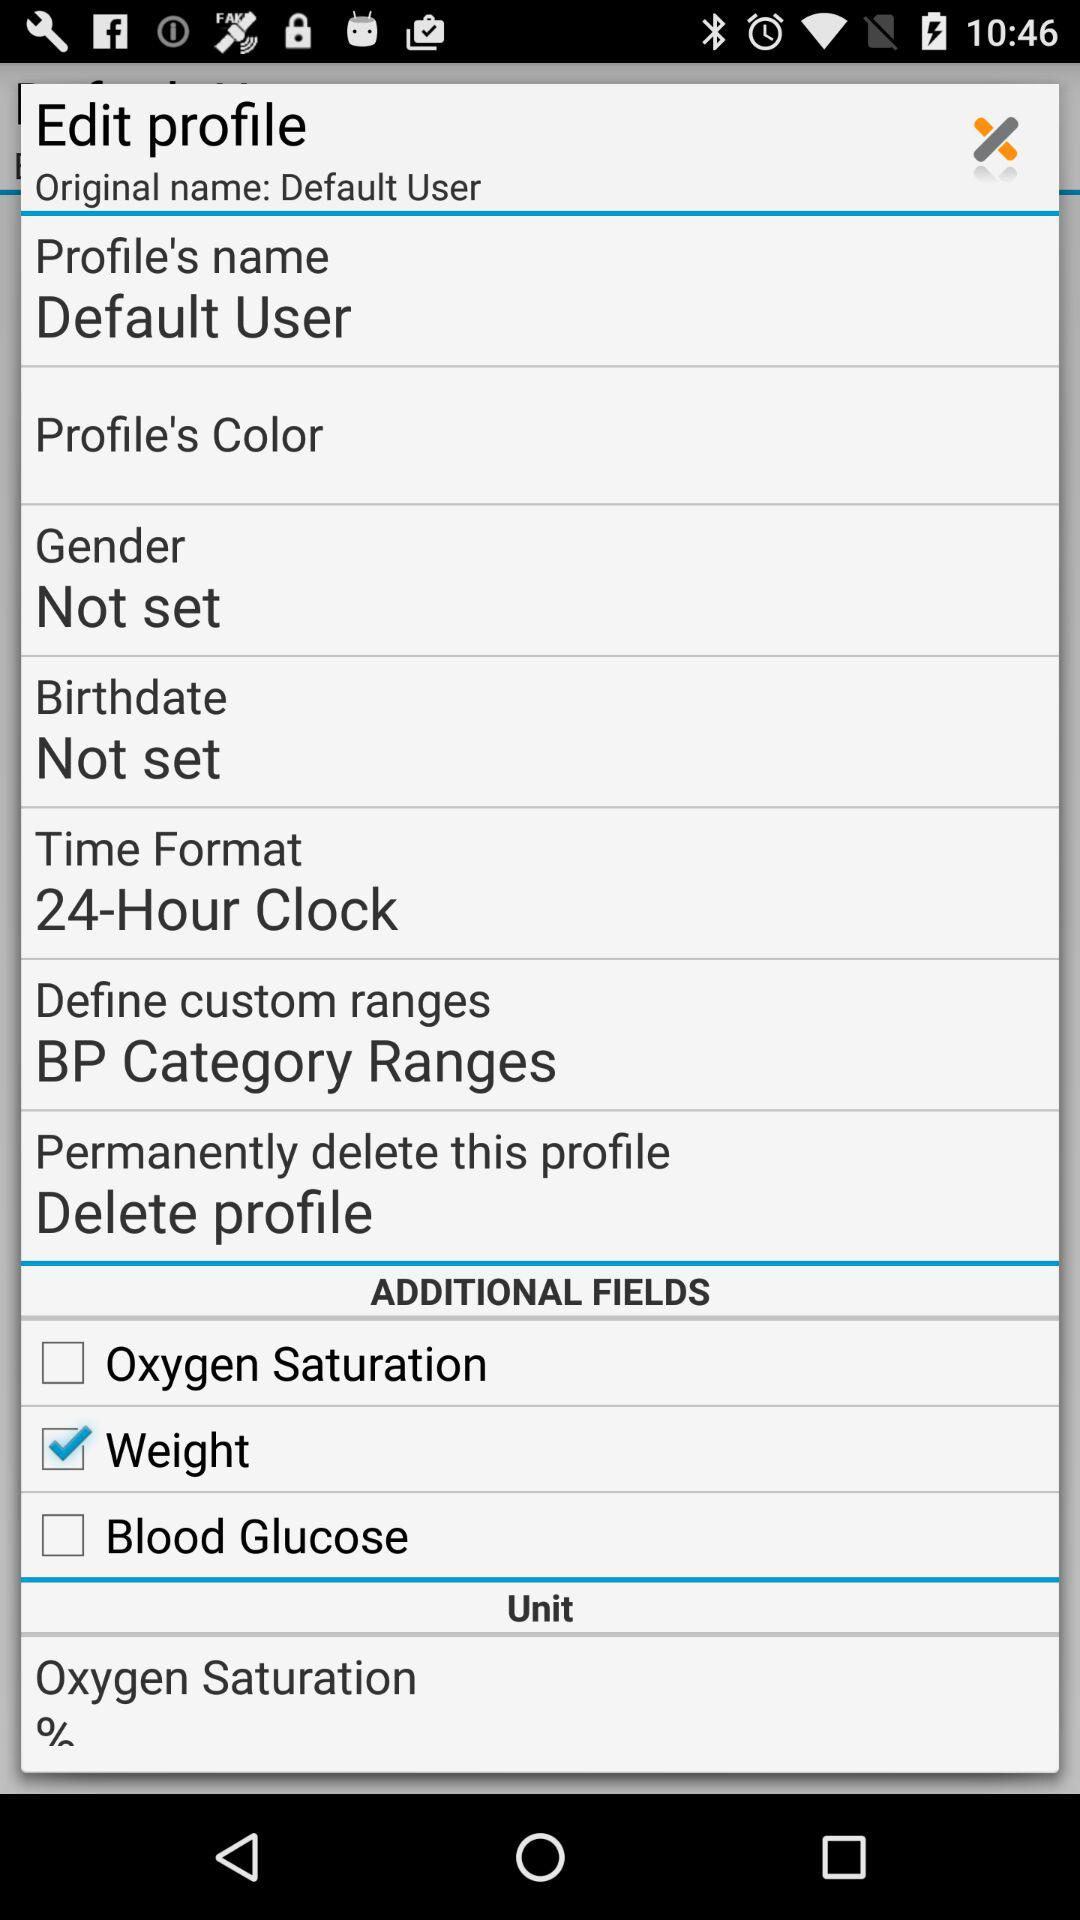Which option is selected in the additional fields? The selected option is Weight. 